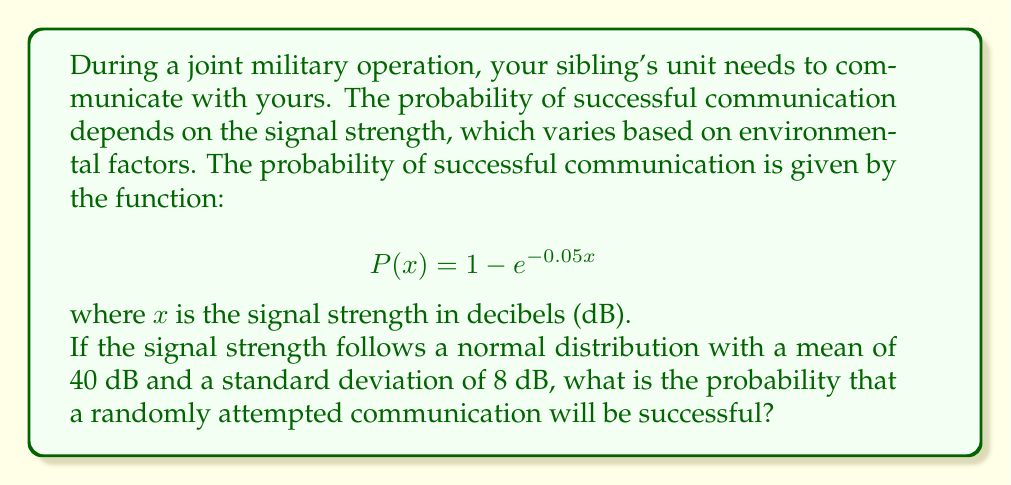Provide a solution to this math problem. To solve this problem, we need to use the concept of expected value for a continuous random variable. Here's the step-by-step solution:

1) Let X be the random variable representing the signal strength in dB. We're given that X follows a normal distribution with μ = 40 and σ = 8.

2) The probability of successful communication for a given signal strength x is P(x) = 1 - e^(-0.05x).

3) The expected probability of successful communication is given by the expected value of P(X):

   $$E[P(X)] = \int_{-\infty}^{\infty} P(x) \cdot f(x) dx$$

   where f(x) is the probability density function of X.

4) For a normal distribution, the probability density function is:

   $$f(x) = \frac{1}{\sigma\sqrt{2\pi}} e^{-\frac{(x-\mu)^2}{2\sigma^2}}$$

5) Substituting our function and the PDF:

   $$E[P(X)] = \int_{-\infty}^{\infty} (1 - e^{-0.05x}) \cdot \frac{1}{8\sqrt{2\pi}} e^{-\frac{(x-40)^2}{2(8^2)}} dx$$

6) This integral is complex and doesn't have a simple closed-form solution. In practice, we would use numerical integration methods to evaluate it.

7) Using a computational tool (like Python with SciPy), we can evaluate this integral numerically.

8) The result of this numerical integration is approximately 0.8646.
Answer: The probability that a randomly attempted communication will be successful is approximately 0.8646 or 86.46%. 